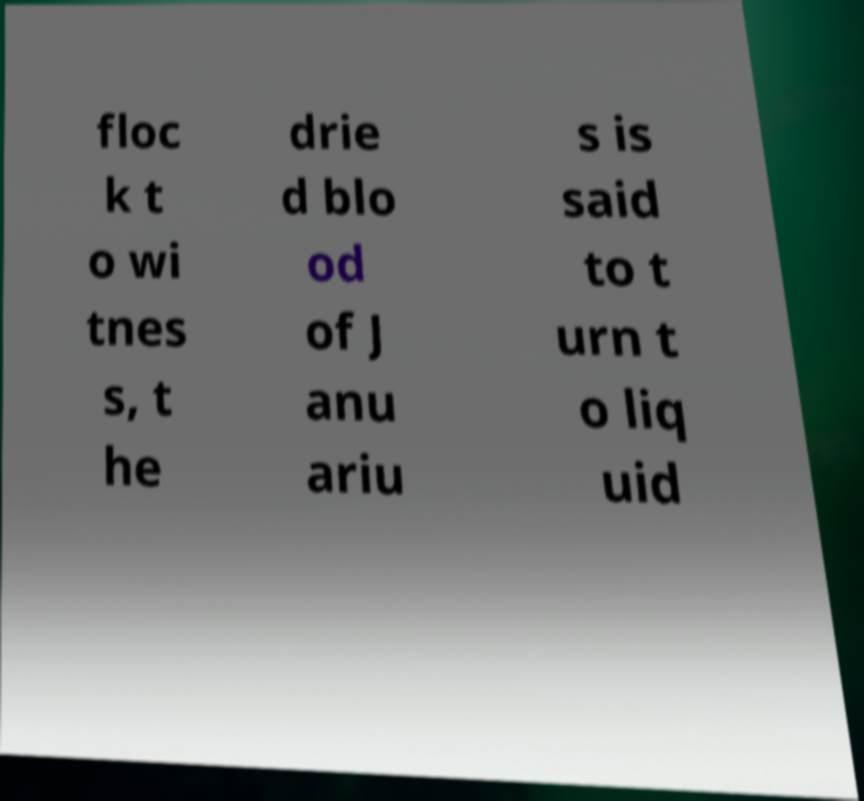Can you read and provide the text displayed in the image?This photo seems to have some interesting text. Can you extract and type it out for me? floc k t o wi tnes s, t he drie d blo od of J anu ariu s is said to t urn t o liq uid 